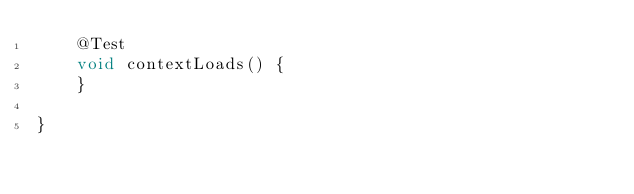<code> <loc_0><loc_0><loc_500><loc_500><_Java_>	@Test
	void contextLoads() {
	}

}
</code> 